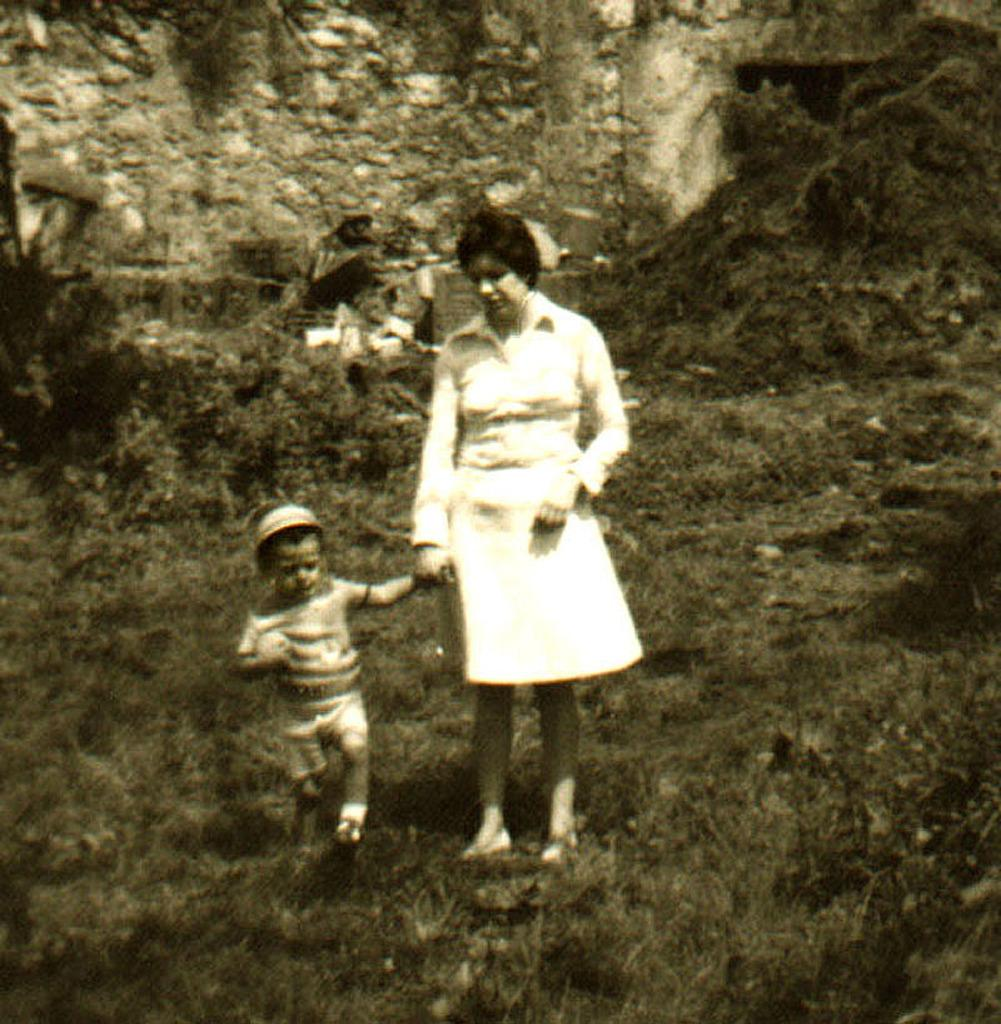What is: What is the color scheme of the image? The image is black and white. How many people can be seen in the image? There are a few people in the image. What is visible beneath the people's feet? The ground is visible in the image. What type of vegetation is present in the image? There is grass and plants in the image. What else can be seen in the image besides the people and vegetation? There are objects and a wall in the image. What is the weight of the library in the image? There is no library present in the image, so it is not possible to determine its weight. 